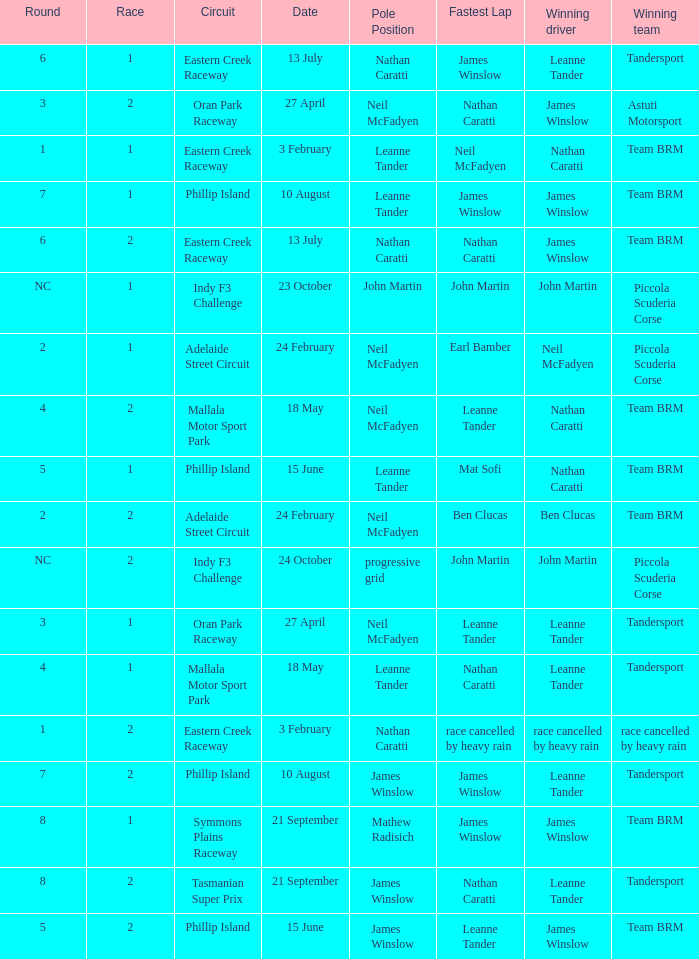In the indy f3 challenge circuit, which race number had john martin starting in pole position? 1.0. 